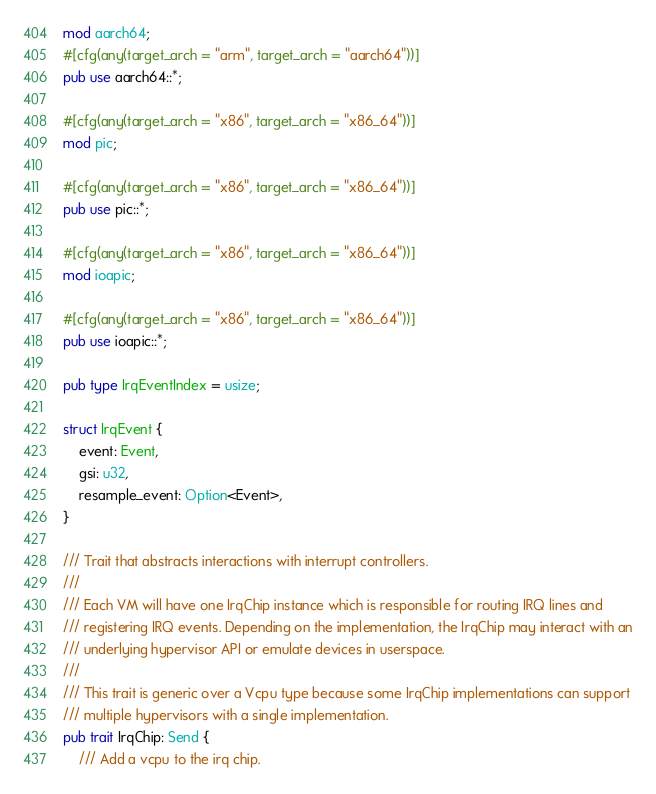<code> <loc_0><loc_0><loc_500><loc_500><_Rust_>mod aarch64;
#[cfg(any(target_arch = "arm", target_arch = "aarch64"))]
pub use aarch64::*;

#[cfg(any(target_arch = "x86", target_arch = "x86_64"))]
mod pic;

#[cfg(any(target_arch = "x86", target_arch = "x86_64"))]
pub use pic::*;

#[cfg(any(target_arch = "x86", target_arch = "x86_64"))]
mod ioapic;

#[cfg(any(target_arch = "x86", target_arch = "x86_64"))]
pub use ioapic::*;

pub type IrqEventIndex = usize;

struct IrqEvent {
    event: Event,
    gsi: u32,
    resample_event: Option<Event>,
}

/// Trait that abstracts interactions with interrupt controllers.
///
/// Each VM will have one IrqChip instance which is responsible for routing IRQ lines and
/// registering IRQ events. Depending on the implementation, the IrqChip may interact with an
/// underlying hypervisor API or emulate devices in userspace.
///
/// This trait is generic over a Vcpu type because some IrqChip implementations can support
/// multiple hypervisors with a single implementation.
pub trait IrqChip: Send {
    /// Add a vcpu to the irq chip.</code> 